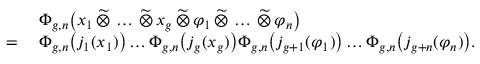Convert formula to latex. <formula><loc_0><loc_0><loc_500><loc_500>\begin{array} { r l } & { \Phi _ { g , n } \left ( x _ { 1 } \, \widetilde { \otimes } \, \dots \, \widetilde { \otimes } \, x _ { g } \, \widetilde { \otimes } \, \varphi _ { 1 } \, \widetilde { \otimes } \, \dots \, \widetilde { \otimes } \, \varphi _ { n } \right ) } \\ { = \, } & { \Phi _ { g , n } \left ( j _ { 1 } ( x _ { 1 } ) \right ) \dots \Phi _ { g , n } \left ( j _ { g } ( x _ { g } ) \right ) \Phi _ { g , n } \left ( j _ { g + 1 } ( \varphi _ { 1 } ) \right ) \dots \Phi _ { g , n } \left ( j _ { g + n } ( \varphi _ { n } ) \right ) . } \end{array}</formula> 